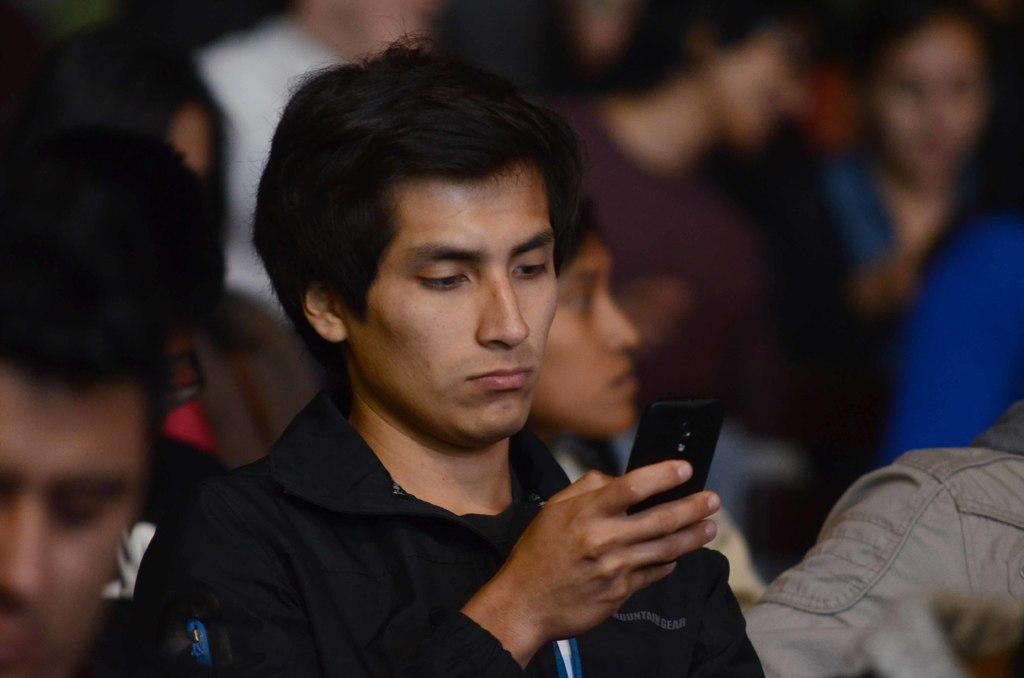How would you summarize this image in a sentence or two? In this picture a person is staring at his mobile phone held in his right hand and some of the people in the background setting 